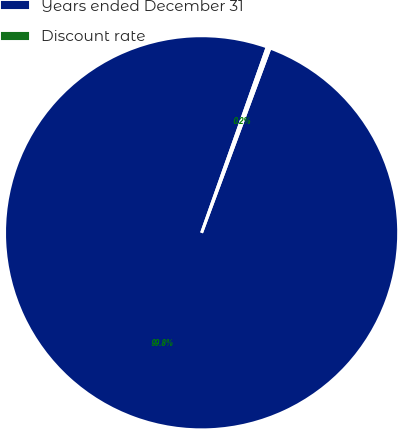Convert chart. <chart><loc_0><loc_0><loc_500><loc_500><pie_chart><fcel>Years ended December 31<fcel>Discount rate<nl><fcel>99.76%<fcel>0.24%<nl></chart> 